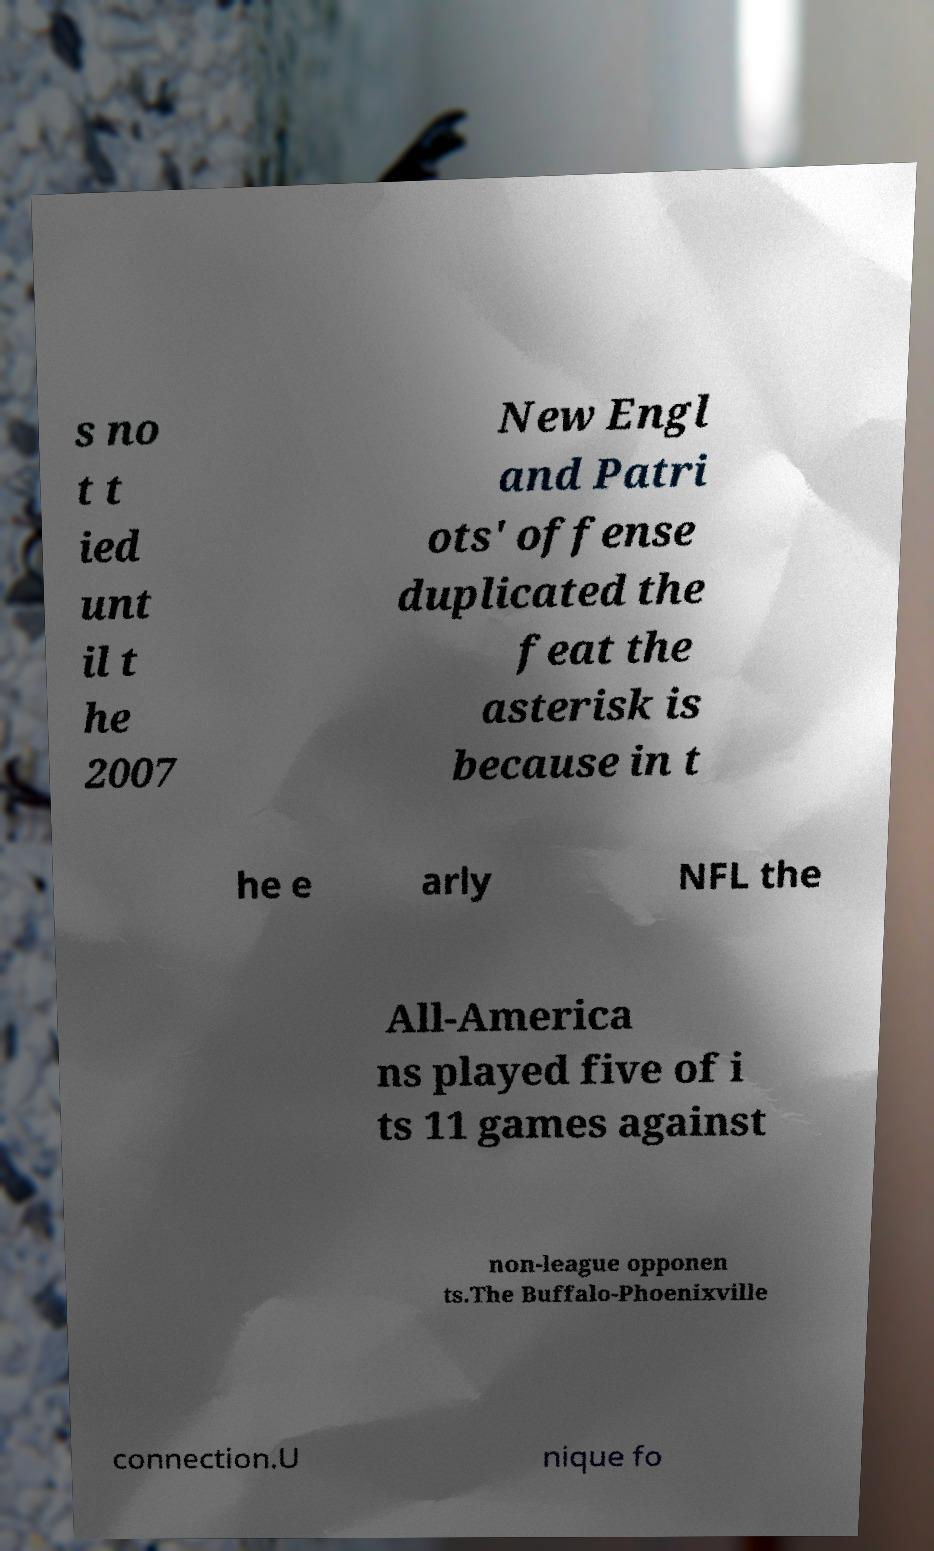Could you extract and type out the text from this image? s no t t ied unt il t he 2007 New Engl and Patri ots' offense duplicated the feat the asterisk is because in t he e arly NFL the All-America ns played five of i ts 11 games against non-league opponen ts.The Buffalo-Phoenixville connection.U nique fo 